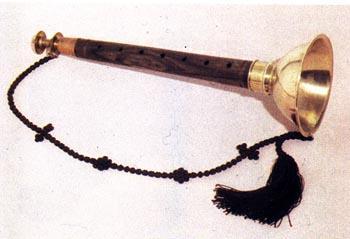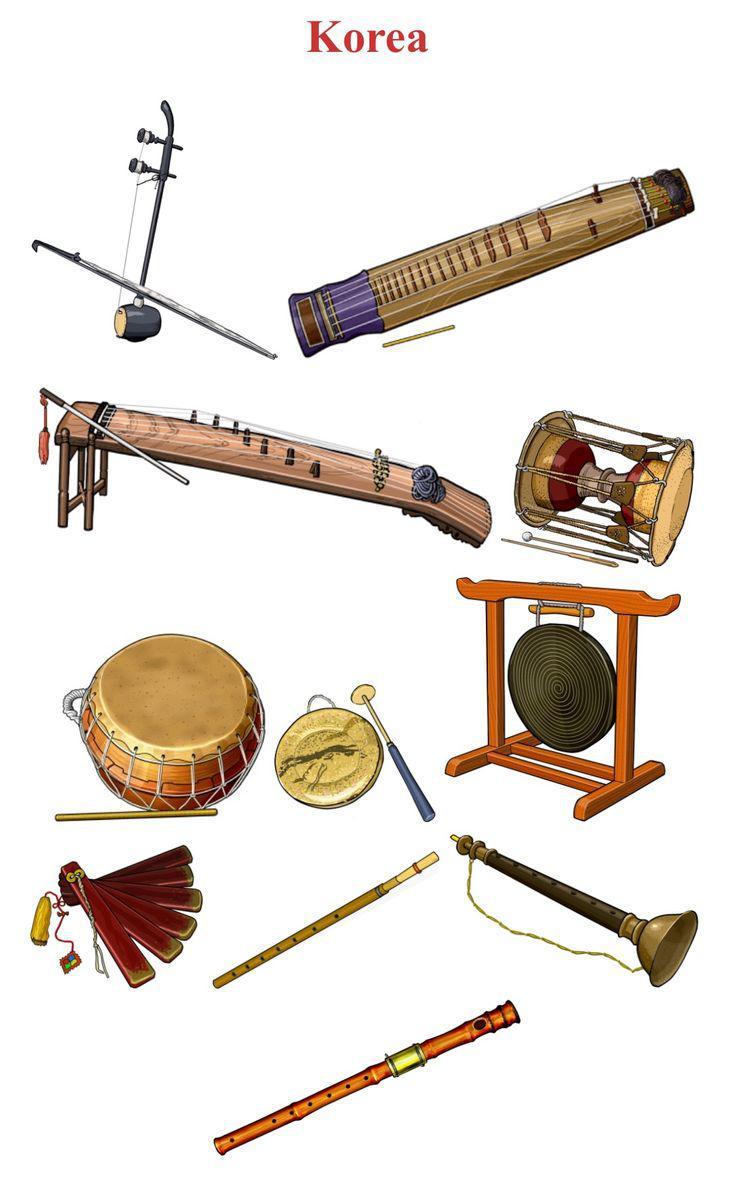The first image is the image on the left, the second image is the image on the right. Analyze the images presented: Is the assertion "Each image shows one bamboo flute displayed horizontally above a white card and beneath Asian characters superimposed over pink and blue color patches." valid? Answer yes or no. No. The first image is the image on the left, the second image is the image on the right. Given the left and right images, does the statement "Each of the instruments has an information card next to it." hold true? Answer yes or no. No. 